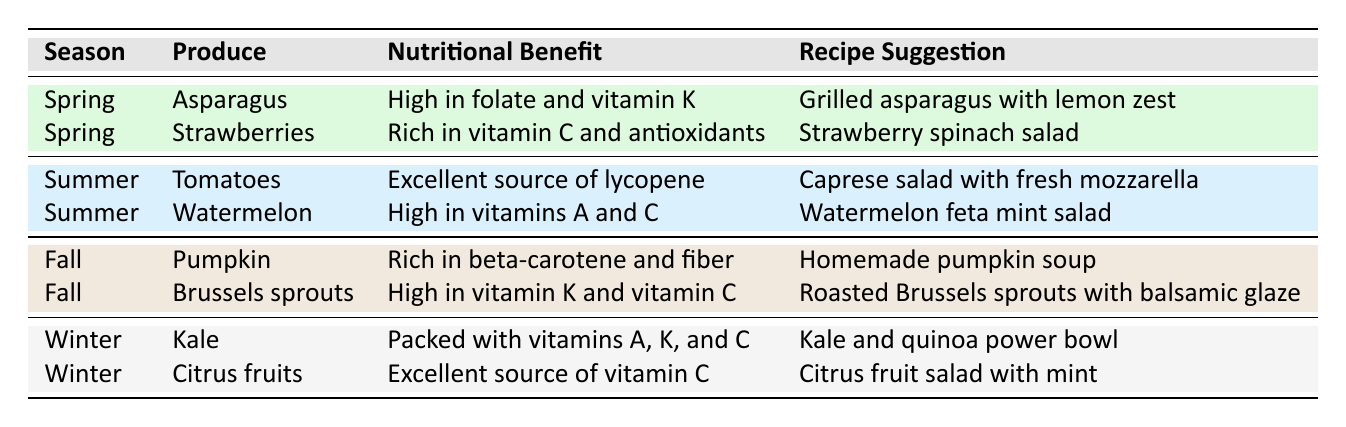What's the nutritional benefit of strawberries? The table lists that strawberries are rich in vitamin C and antioxidants under the "Nutritional Benefit" column for the "Spring" season.
Answer: Rich in vitamin C and antioxidants Which produce is high in vitamin K? By analyzing the table, asparagus and Brussels sprouts are both listed under their respective seasons (spring and fall) with the nutritional benefit of being high in vitamin K. Therefore, both can be considered correct.
Answer: Asparagus and Brussels sprouts Are tomatoes a summer produce? The table indicates that tomatoes fall under the "Summer" category in the "Season" column, confirming that they are indeed a summer produce.
Answer: Yes What is the nutritional benefit of pumpkin? The table states that pumpkin is rich in beta-carotene and fiber, which is explicitly listed in the "Nutritional Benefit" column for the "Fall" season.
Answer: Rich in beta-carotene and fiber Which season has produce that is packed with vitamins A, K, and C? Referring to the table, kale is listed under the "Winter" season with the nutritional benefit of being packed with vitamins A, K, and C. Therefore, winter is the season that has such produce.
Answer: Winter 